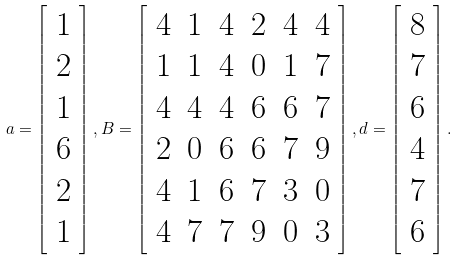<formula> <loc_0><loc_0><loc_500><loc_500>a = \left [ \begin{array} { c } 1 \\ 2 \\ 1 \\ 6 \\ 2 \\ 1 \end{array} \right ] , B = \left [ \begin{array} { c c c c c c } 4 & 1 & 4 & 2 & 4 & 4 \\ 1 & 1 & 4 & 0 & 1 & 7 \\ 4 & 4 & 4 & 6 & 6 & 7 \\ 2 & 0 & 6 & 6 & 7 & 9 \\ 4 & 1 & 6 & 7 & 3 & 0 \\ 4 & 7 & 7 & 9 & 0 & 3 \end{array} \right ] , d = \left [ \begin{array} { c } 8 \\ 7 \\ 6 \\ 4 \\ 7 \\ 6 \end{array} \right ] .</formula> 